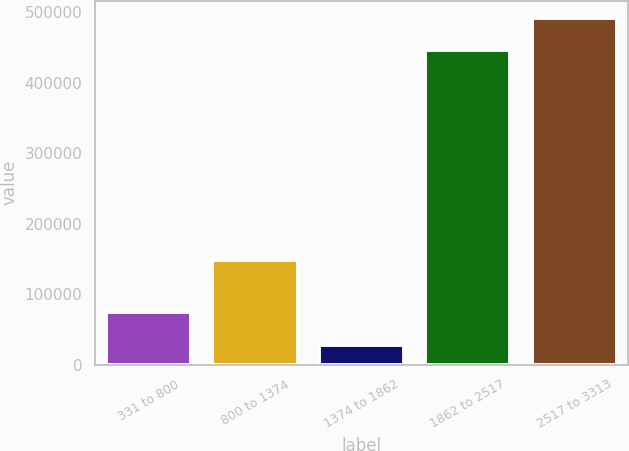Convert chart to OTSL. <chart><loc_0><loc_0><loc_500><loc_500><bar_chart><fcel>331 to 800<fcel>800 to 1374<fcel>1374 to 1862<fcel>1862 to 2517<fcel>2517 to 3313<nl><fcel>74165.5<fcel>148556<fcel>28374<fcel>446575<fcel>492366<nl></chart> 